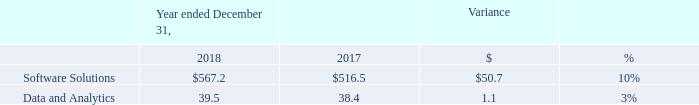EBITDA and EBITDA Margin
The following tables set forth EBITDA (in millions) and EBITDA Margin by segment for the periods presented:
Software Solutions
EBITDA was $567.2 million in 2018 compared to $516.5 million in 2017, an increase of $50.7 million, or 10%, with an EBITDA Margin of 59.0%, an increase of 190 basis points from the prior year. The increase was primarily driven by incremental margins on revenue growth.
Data and Analytics
EBITDA was $39.5 million in 2018 compared to $38.4 million in 2017, an increase of $1.1 million, or 3%, with an EBITDA Margin of 25.6%, an increase of 30 basis points from the prior year. The EBITDA Margin increase was primarily driven by incremental margins on revenue growth.
What was increase in EBITDA for Software Solutions?
Answer scale should be: million. 50.7. What was the increase in the EBITDA for Data and Analytics?
Answer scale should be: million. 1.1. Which years does the table provide information for the EBITDA by segment? 2018, 2017. How many years did EBITDA for Software Solutions exceed $500 million? 2018##2017
Answer: 2. What was the sum of the EBITDA in 2018?
Answer scale should be: million. 567.2+39.5
Answer: 606.7. Which segments did the percent variance exceed 5%? (Software Solutions:10%)
Answer: software solutions. 